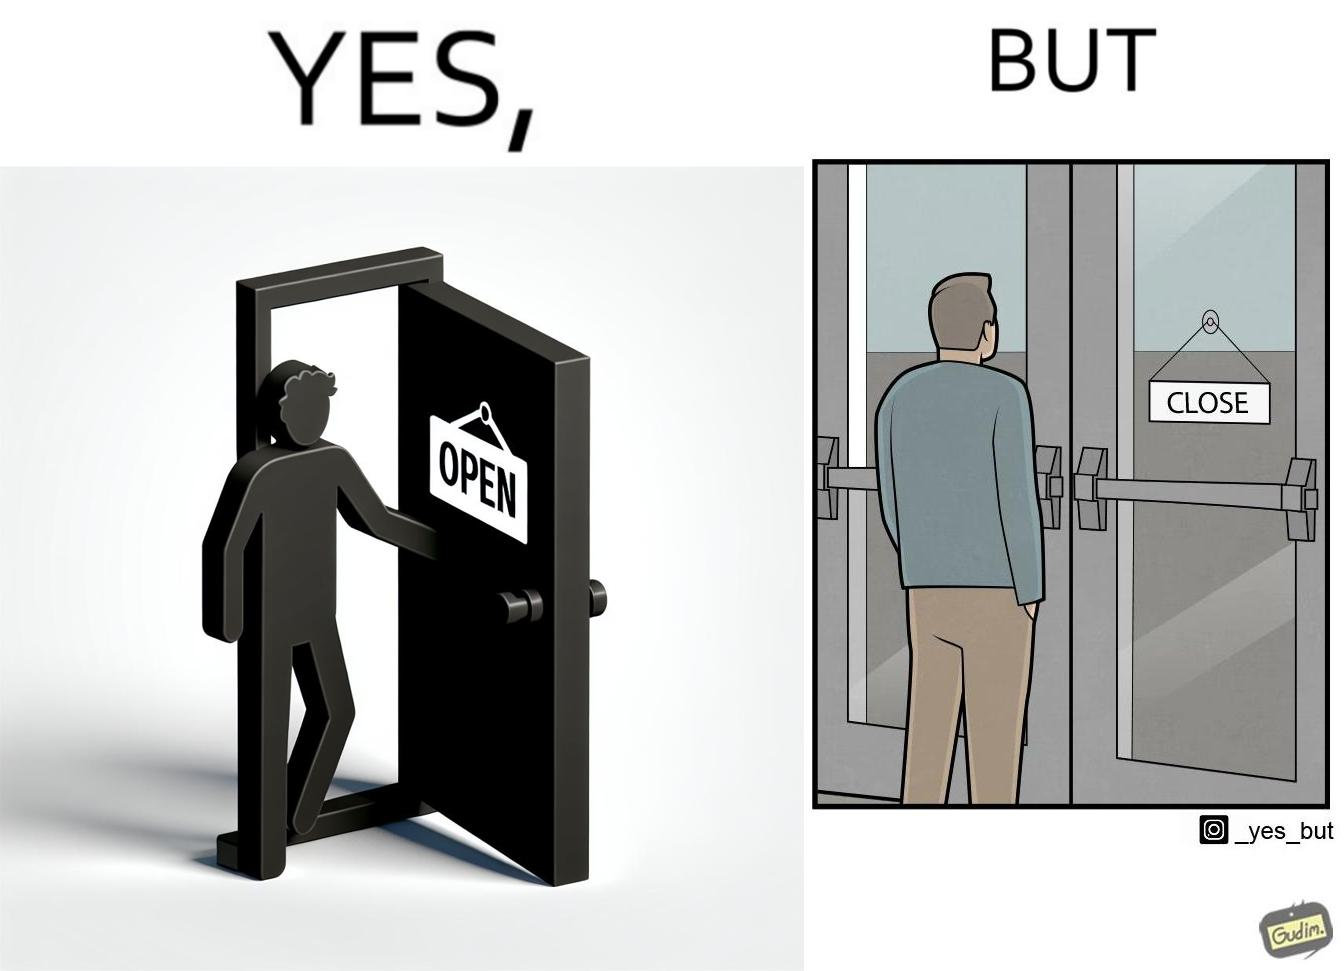What is shown in this image? The image is funny because a person opens a door with the sign 'OPEN', meaning the place is open. However, once the person enters the building and looks back, the other side of the sign reads 'CLOSE', which ideally should not be the case, as the place is actually open. 